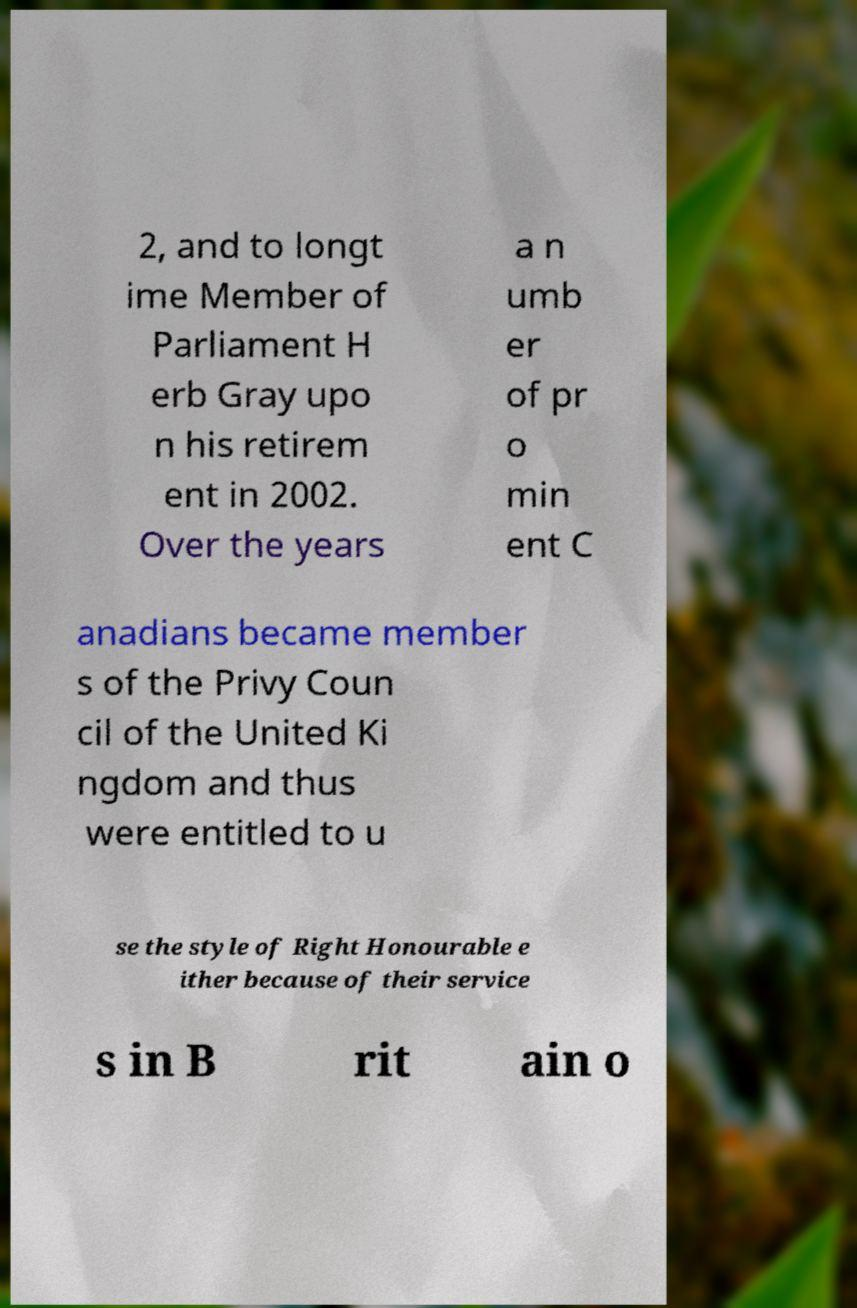Please identify and transcribe the text found in this image. 2, and to longt ime Member of Parliament H erb Gray upo n his retirem ent in 2002. Over the years a n umb er of pr o min ent C anadians became member s of the Privy Coun cil of the United Ki ngdom and thus were entitled to u se the style of Right Honourable e ither because of their service s in B rit ain o 